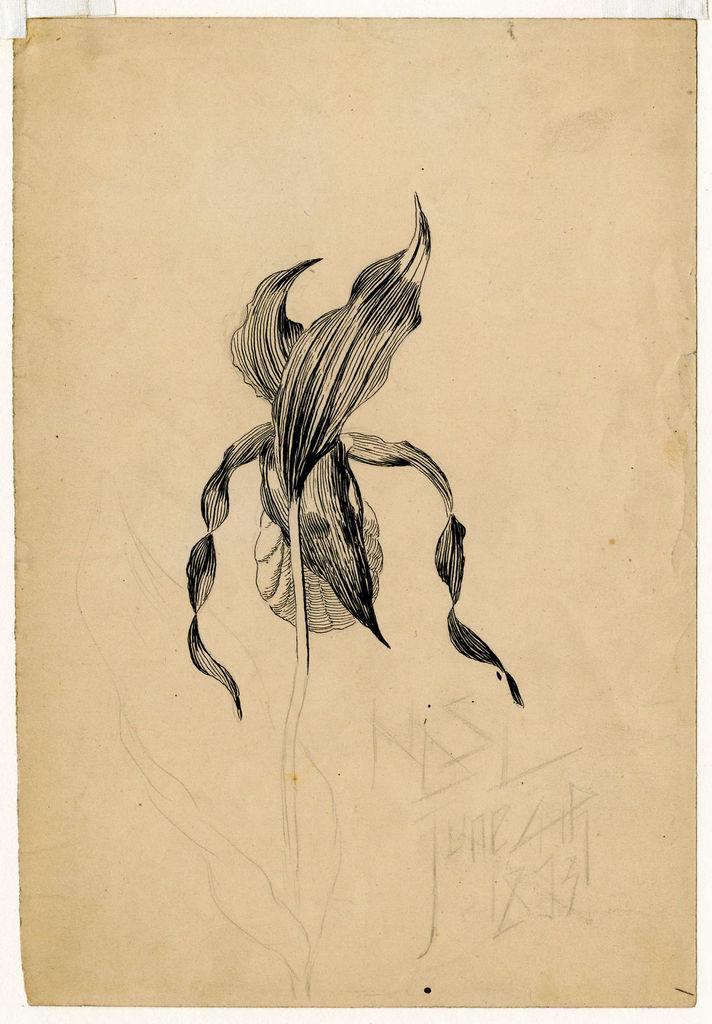How would you summarize this image in a sentence or two? In the middle of this image, there is a painting of a plant having leaves. Beside this painting, there is a drawing. 